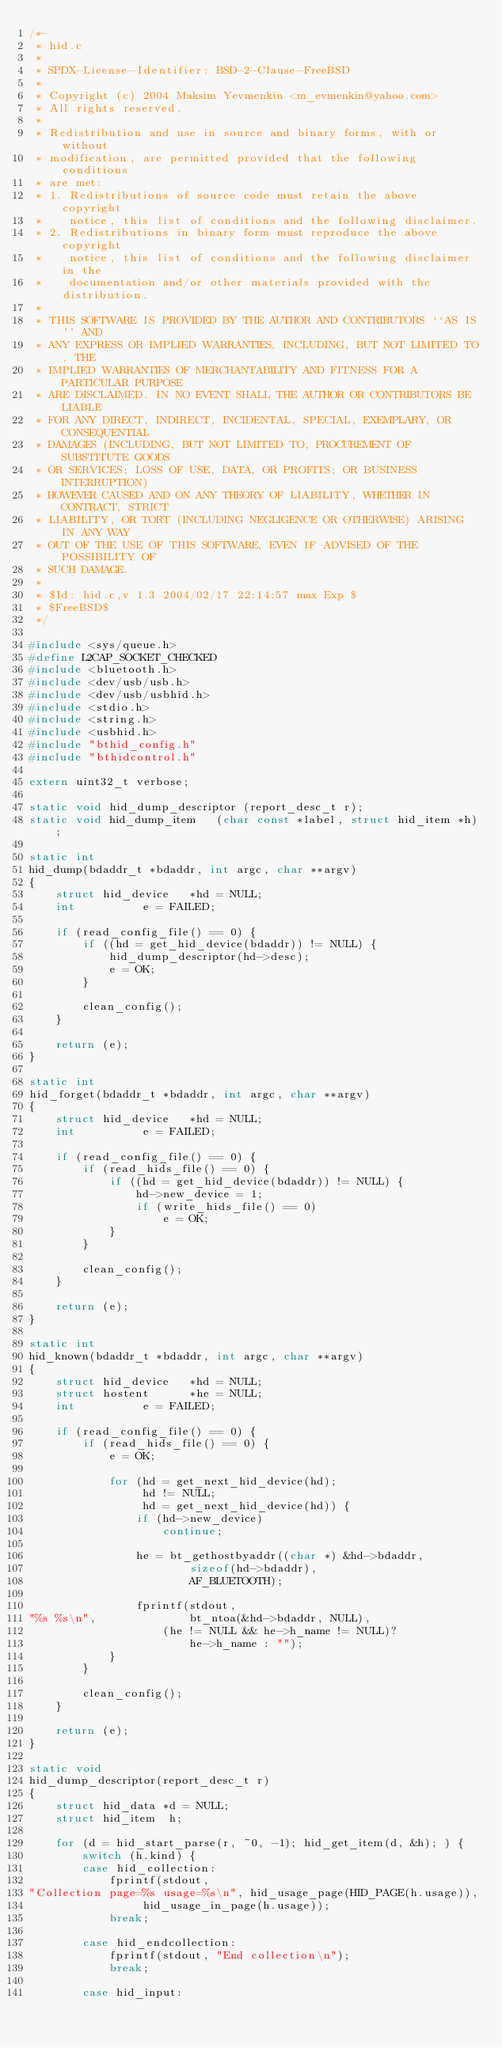Convert code to text. <code><loc_0><loc_0><loc_500><loc_500><_C_>/*-
 * hid.c
 *
 * SPDX-License-Identifier: BSD-2-Clause-FreeBSD
 *
 * Copyright (c) 2004 Maksim Yevmenkin <m_evmenkin@yahoo.com>
 * All rights reserved.
 *
 * Redistribution and use in source and binary forms, with or without
 * modification, are permitted provided that the following conditions
 * are met:
 * 1. Redistributions of source code must retain the above copyright
 *    notice, this list of conditions and the following disclaimer.
 * 2. Redistributions in binary form must reproduce the above copyright
 *    notice, this list of conditions and the following disclaimer in the
 *    documentation and/or other materials provided with the distribution.
 *
 * THIS SOFTWARE IS PROVIDED BY THE AUTHOR AND CONTRIBUTORS ``AS IS'' AND
 * ANY EXPRESS OR IMPLIED WARRANTIES, INCLUDING, BUT NOT LIMITED TO, THE
 * IMPLIED WARRANTIES OF MERCHANTABILITY AND FITNESS FOR A PARTICULAR PURPOSE
 * ARE DISCLAIMED. IN NO EVENT SHALL THE AUTHOR OR CONTRIBUTORS BE LIABLE
 * FOR ANY DIRECT, INDIRECT, INCIDENTAL, SPECIAL, EXEMPLARY, OR CONSEQUENTIAL
 * DAMAGES (INCLUDING, BUT NOT LIMITED TO, PROCUREMENT OF SUBSTITUTE GOODS
 * OR SERVICES; LOSS OF USE, DATA, OR PROFITS; OR BUSINESS INTERRUPTION)
 * HOWEVER CAUSED AND ON ANY THEORY OF LIABILITY, WHETHER IN CONTRACT, STRICT
 * LIABILITY, OR TORT (INCLUDING NEGLIGENCE OR OTHERWISE) ARISING IN ANY WAY
 * OUT OF THE USE OF THIS SOFTWARE, EVEN IF ADVISED OF THE POSSIBILITY OF
 * SUCH DAMAGE.
 *
 * $Id: hid.c,v 1.3 2004/02/17 22:14:57 max Exp $
 * $FreeBSD$
 */

#include <sys/queue.h>
#define L2CAP_SOCKET_CHECKED
#include <bluetooth.h>
#include <dev/usb/usb.h>
#include <dev/usb/usbhid.h>
#include <stdio.h>
#include <string.h>
#include <usbhid.h>
#include "bthid_config.h"
#include "bthidcontrol.h"

extern uint32_t verbose;

static void hid_dump_descriptor	(report_desc_t r);
static void hid_dump_item	(char const *label, struct hid_item *h);

static int
hid_dump(bdaddr_t *bdaddr, int argc, char **argv)
{
	struct hid_device	*hd = NULL;
	int			 e = FAILED;

	if (read_config_file() == 0) {
		if ((hd = get_hid_device(bdaddr)) != NULL) {
			hid_dump_descriptor(hd->desc);
			e = OK;
		} 

		clean_config();
	}

	return (e);
}

static int
hid_forget(bdaddr_t *bdaddr, int argc, char **argv)
{
	struct hid_device	*hd = NULL;
	int			 e = FAILED;

	if (read_config_file() == 0) {
		if (read_hids_file() == 0) {
			if ((hd = get_hid_device(bdaddr)) != NULL) {
				hd->new_device = 1;
				if (write_hids_file() == 0)
					e = OK;
			}
		}

		clean_config();
	}

	return (e);
}

static int
hid_known(bdaddr_t *bdaddr, int argc, char **argv)
{
	struct hid_device	*hd = NULL;
	struct hostent		*he = NULL;
	int			 e = FAILED;

	if (read_config_file() == 0) {
		if (read_hids_file() == 0) {
			e = OK;

			for (hd = get_next_hid_device(hd);
			     hd != NULL;
			     hd = get_next_hid_device(hd)) {
				if (hd->new_device)
					continue;

				he = bt_gethostbyaddr((char *) &hd->bdaddr,
						sizeof(hd->bdaddr),
						AF_BLUETOOTH);

				fprintf(stdout,
"%s %s\n",				bt_ntoa(&hd->bdaddr, NULL),
					(he != NULL && he->h_name != NULL)?
						he->h_name : "");
			}
		}

		clean_config();
	}

	return (e);
}

static void
hid_dump_descriptor(report_desc_t r)
{
	struct hid_data	*d = NULL;
	struct hid_item	 h;

	for (d = hid_start_parse(r, ~0, -1); hid_get_item(d, &h); ) {
		switch (h.kind) {
		case hid_collection:
			fprintf(stdout,
"Collection page=%s usage=%s\n", hid_usage_page(HID_PAGE(h.usage)),
				 hid_usage_in_page(h.usage));
			break;

		case hid_endcollection:
			fprintf(stdout, "End collection\n");
			break;

		case hid_input:</code> 